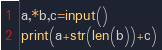Convert code to text. <code><loc_0><loc_0><loc_500><loc_500><_Python_>a,*b,c=input()
print(a+str(len(b))+c)</code> 